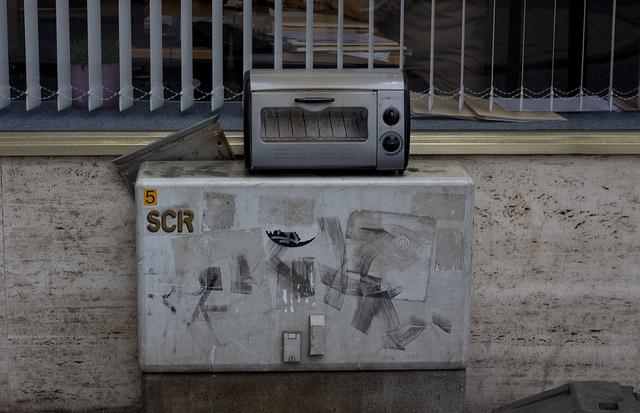What is the appliance sitting on?
Keep it brief. Box. What is the white appliance?
Be succinct. Toaster. Do you see flowers in this picture?
Quick response, please. No. What was inside the box?
Concise answer only. Wires. What appliance is abandoned here?
Answer briefly. Toaster oven. What appliance is this?
Short answer required. Toaster oven. Is this photo taken outside?
Keep it brief. Yes. 